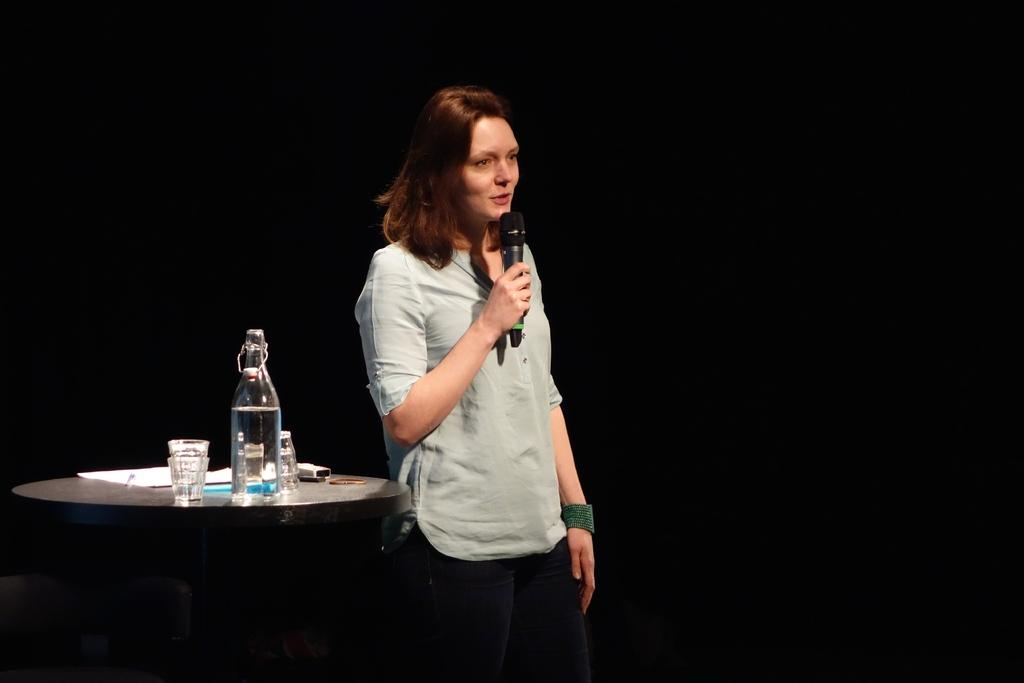What is the woman in the image doing? The woman is standing in the image and holding a microphone in her hand. What can be seen on the table in the image? The table has a bottle, glasses, remote, and papers on it. What is the color of the background in the image? The background of the image is black. What type of sign is the woman holding in the image? There is no sign present in the image; the woman is holding a microphone. What is the woman's head made of in the image? The woman's head is made of the same material as the rest of her body, which is not specified in the image. 